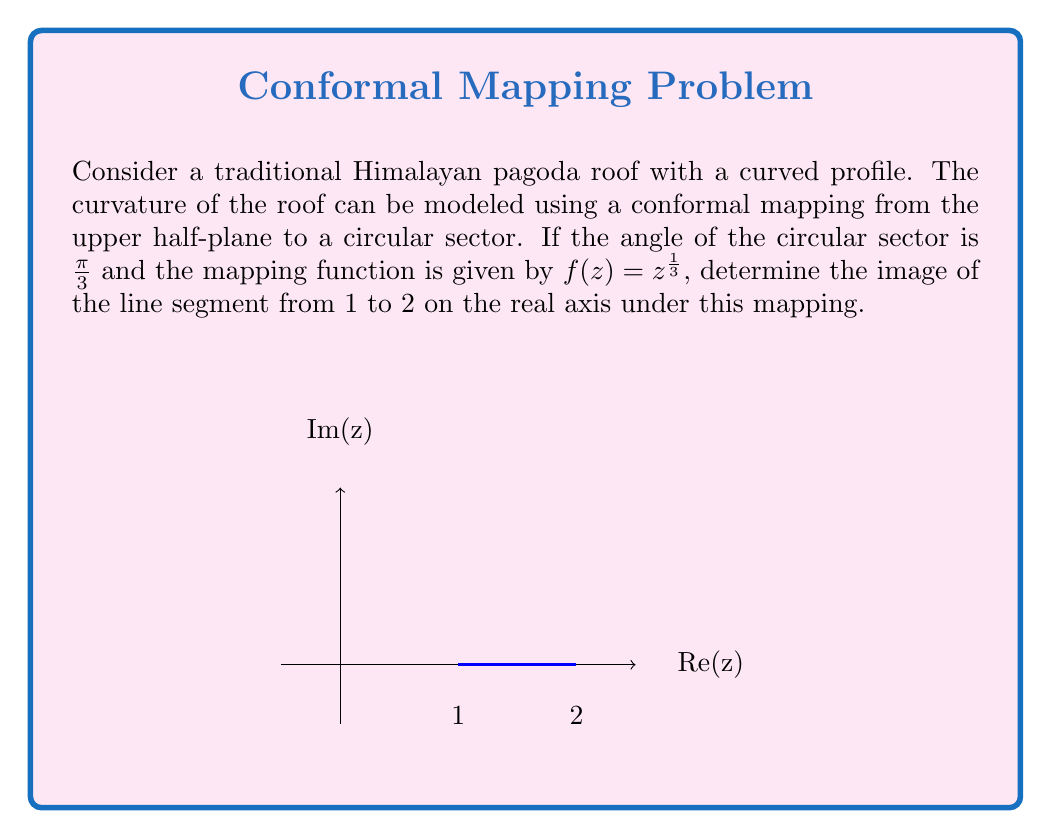Give your solution to this math problem. Let's approach this step-by-step:

1) The conformal mapping $f(z) = z^{\frac{1}{3}}$ maps the upper half-plane to a circular sector with angle $\frac{\pi}{3}$.

2) For any point $z = x + yi$ on the real axis (where $y = 0$), we have:

   $f(z) = (x + 0i)^{\frac{1}{3}} = x^{\frac{1}{3}}(\cos(\frac{\theta}{3}) + i\sin(\frac{\theta}{3}))$

   where $\theta = 0$ for positive real numbers.

3) For the line segment from 1 to 2:
   
   At $z = 1$: $f(1) = 1^{\frac{1}{3}} = 1$
   
   At $z = 2$: $f(2) = 2^{\frac{1}{3}} = \sqrt[3]{2} \approx 1.26$

4) The image of this line segment will be an arc on the real axis from 1 to $\sqrt[3]{2}$.

5) To visualize this, imagine the entire positive real axis being "compressed" by the cube root function, with points closer to 0 being stretched out more than points further from 0.

[asy]
import graph;
size(200);

real f(real x) {return x^(1/3);}

draw(graph(f,0,2.5), blue);
draw((0,0)--(2.5,0), arrow=Arrow(TeXHead));
draw((0,0)--(0,1.5), arrow=Arrow(TeXHead));

draw((1,0)--(2^(1/3),0), red+linewidth(2));
dot((1,0));
dot((2^(1/3),0));

label("1", (1,0), S);
label("$\sqrt[3]{2}$", (2^(1/3),0), S);
label("Re(w)", (2.5,0), E);
label("Im(w)", (0,1.5), N);
[/asy]
Answer: $[1, \sqrt[3]{2}]$ on the real axis 